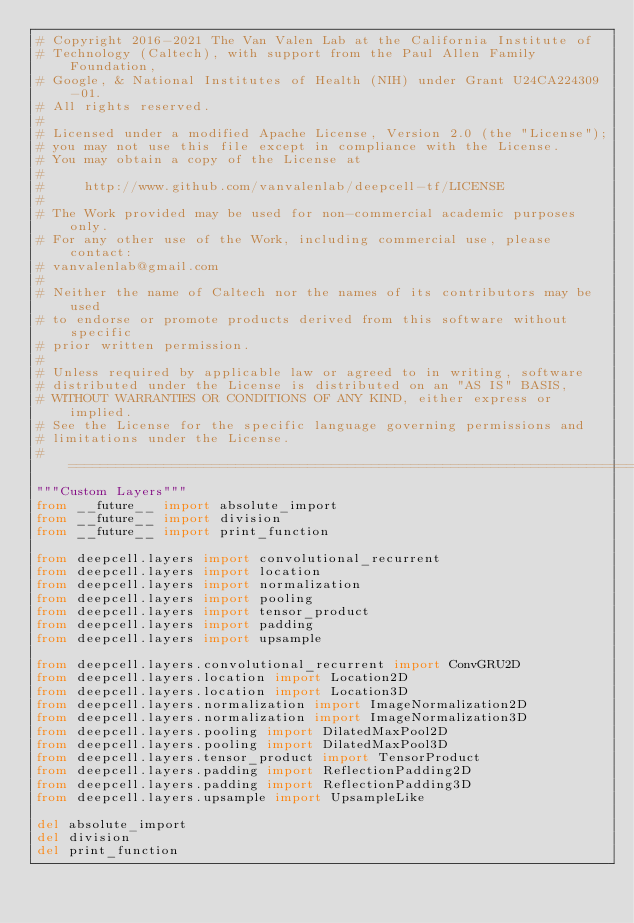Convert code to text. <code><loc_0><loc_0><loc_500><loc_500><_Python_># Copyright 2016-2021 The Van Valen Lab at the California Institute of
# Technology (Caltech), with support from the Paul Allen Family Foundation,
# Google, & National Institutes of Health (NIH) under Grant U24CA224309-01.
# All rights reserved.
#
# Licensed under a modified Apache License, Version 2.0 (the "License");
# you may not use this file except in compliance with the License.
# You may obtain a copy of the License at
#
#     http://www.github.com/vanvalenlab/deepcell-tf/LICENSE
#
# The Work provided may be used for non-commercial academic purposes only.
# For any other use of the Work, including commercial use, please contact:
# vanvalenlab@gmail.com
#
# Neither the name of Caltech nor the names of its contributors may be used
# to endorse or promote products derived from this software without specific
# prior written permission.
#
# Unless required by applicable law or agreed to in writing, software
# distributed under the License is distributed on an "AS IS" BASIS,
# WITHOUT WARRANTIES OR CONDITIONS OF ANY KIND, either express or implied.
# See the License for the specific language governing permissions and
# limitations under the License.
# ==============================================================================
"""Custom Layers"""
from __future__ import absolute_import
from __future__ import division
from __future__ import print_function

from deepcell.layers import convolutional_recurrent
from deepcell.layers import location
from deepcell.layers import normalization
from deepcell.layers import pooling
from deepcell.layers import tensor_product
from deepcell.layers import padding
from deepcell.layers import upsample

from deepcell.layers.convolutional_recurrent import ConvGRU2D
from deepcell.layers.location import Location2D
from deepcell.layers.location import Location3D
from deepcell.layers.normalization import ImageNormalization2D
from deepcell.layers.normalization import ImageNormalization3D
from deepcell.layers.pooling import DilatedMaxPool2D
from deepcell.layers.pooling import DilatedMaxPool3D
from deepcell.layers.tensor_product import TensorProduct
from deepcell.layers.padding import ReflectionPadding2D
from deepcell.layers.padding import ReflectionPadding3D
from deepcell.layers.upsample import UpsampleLike

del absolute_import
del division
del print_function
</code> 